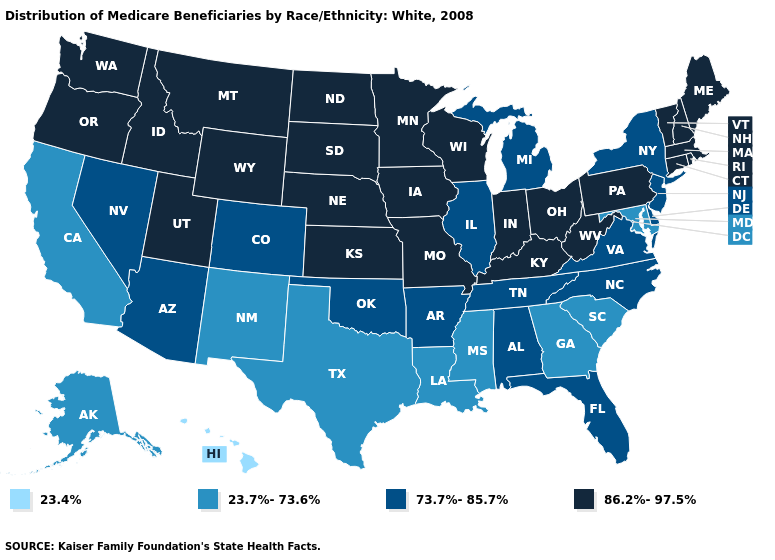Does Michigan have the highest value in the MidWest?
Short answer required. No. What is the value of Hawaii?
Quick response, please. 23.4%. What is the value of Utah?
Give a very brief answer. 86.2%-97.5%. What is the value of Pennsylvania?
Quick response, please. 86.2%-97.5%. Which states have the lowest value in the Northeast?
Short answer required. New Jersey, New York. Does the first symbol in the legend represent the smallest category?
Write a very short answer. Yes. What is the highest value in the West ?
Keep it brief. 86.2%-97.5%. What is the value of New Jersey?
Answer briefly. 73.7%-85.7%. Name the states that have a value in the range 73.7%-85.7%?
Keep it brief. Alabama, Arizona, Arkansas, Colorado, Delaware, Florida, Illinois, Michigan, Nevada, New Jersey, New York, North Carolina, Oklahoma, Tennessee, Virginia. Which states hav the highest value in the West?
Be succinct. Idaho, Montana, Oregon, Utah, Washington, Wyoming. What is the highest value in the USA?
Short answer required. 86.2%-97.5%. Does Minnesota have the same value as Connecticut?
Concise answer only. Yes. What is the value of South Dakota?
Short answer required. 86.2%-97.5%. Does Illinois have the lowest value in the MidWest?
Be succinct. Yes. 